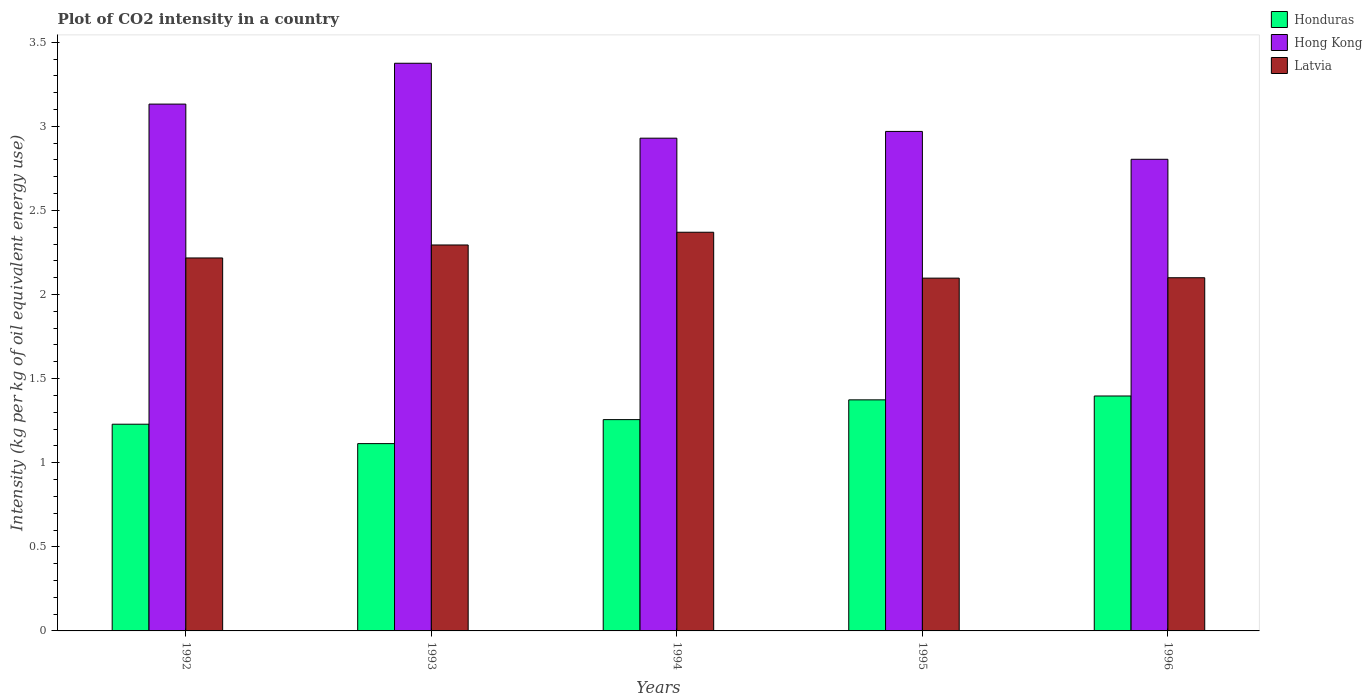How many groups of bars are there?
Provide a short and direct response. 5. How many bars are there on the 3rd tick from the left?
Make the answer very short. 3. What is the label of the 4th group of bars from the left?
Provide a succinct answer. 1995. In how many cases, is the number of bars for a given year not equal to the number of legend labels?
Your response must be concise. 0. What is the CO2 intensity in in Latvia in 1996?
Your answer should be compact. 2.1. Across all years, what is the maximum CO2 intensity in in Latvia?
Provide a succinct answer. 2.37. Across all years, what is the minimum CO2 intensity in in Latvia?
Offer a terse response. 2.1. In which year was the CO2 intensity in in Latvia maximum?
Ensure brevity in your answer.  1994. What is the total CO2 intensity in in Honduras in the graph?
Give a very brief answer. 6.37. What is the difference between the CO2 intensity in in Latvia in 1995 and that in 1996?
Offer a terse response. -0. What is the difference between the CO2 intensity in in Latvia in 1993 and the CO2 intensity in in Honduras in 1996?
Offer a very short reply. 0.9. What is the average CO2 intensity in in Latvia per year?
Keep it short and to the point. 2.22. In the year 1993, what is the difference between the CO2 intensity in in Latvia and CO2 intensity in in Honduras?
Your response must be concise. 1.18. In how many years, is the CO2 intensity in in Honduras greater than 2.1 kg?
Offer a very short reply. 0. What is the ratio of the CO2 intensity in in Hong Kong in 1992 to that in 1993?
Your answer should be very brief. 0.93. Is the CO2 intensity in in Hong Kong in 1992 less than that in 1996?
Ensure brevity in your answer.  No. Is the difference between the CO2 intensity in in Latvia in 1992 and 1996 greater than the difference between the CO2 intensity in in Honduras in 1992 and 1996?
Provide a succinct answer. Yes. What is the difference between the highest and the second highest CO2 intensity in in Honduras?
Make the answer very short. 0.02. What is the difference between the highest and the lowest CO2 intensity in in Honduras?
Provide a succinct answer. 0.28. In how many years, is the CO2 intensity in in Hong Kong greater than the average CO2 intensity in in Hong Kong taken over all years?
Give a very brief answer. 2. Is the sum of the CO2 intensity in in Hong Kong in 1992 and 1994 greater than the maximum CO2 intensity in in Honduras across all years?
Your response must be concise. Yes. What does the 2nd bar from the left in 1992 represents?
Provide a short and direct response. Hong Kong. What does the 2nd bar from the right in 1993 represents?
Give a very brief answer. Hong Kong. Does the graph contain any zero values?
Keep it short and to the point. No. Where does the legend appear in the graph?
Make the answer very short. Top right. What is the title of the graph?
Give a very brief answer. Plot of CO2 intensity in a country. What is the label or title of the Y-axis?
Offer a terse response. Intensity (kg per kg of oil equivalent energy use). What is the Intensity (kg per kg of oil equivalent energy use) in Honduras in 1992?
Give a very brief answer. 1.23. What is the Intensity (kg per kg of oil equivalent energy use) of Hong Kong in 1992?
Offer a terse response. 3.13. What is the Intensity (kg per kg of oil equivalent energy use) of Latvia in 1992?
Your response must be concise. 2.22. What is the Intensity (kg per kg of oil equivalent energy use) of Honduras in 1993?
Offer a terse response. 1.11. What is the Intensity (kg per kg of oil equivalent energy use) of Hong Kong in 1993?
Provide a short and direct response. 3.38. What is the Intensity (kg per kg of oil equivalent energy use) of Latvia in 1993?
Keep it short and to the point. 2.29. What is the Intensity (kg per kg of oil equivalent energy use) of Honduras in 1994?
Ensure brevity in your answer.  1.26. What is the Intensity (kg per kg of oil equivalent energy use) of Hong Kong in 1994?
Your response must be concise. 2.93. What is the Intensity (kg per kg of oil equivalent energy use) in Latvia in 1994?
Your answer should be compact. 2.37. What is the Intensity (kg per kg of oil equivalent energy use) of Honduras in 1995?
Provide a short and direct response. 1.37. What is the Intensity (kg per kg of oil equivalent energy use) of Hong Kong in 1995?
Keep it short and to the point. 2.97. What is the Intensity (kg per kg of oil equivalent energy use) of Latvia in 1995?
Your answer should be very brief. 2.1. What is the Intensity (kg per kg of oil equivalent energy use) of Honduras in 1996?
Ensure brevity in your answer.  1.4. What is the Intensity (kg per kg of oil equivalent energy use) in Hong Kong in 1996?
Give a very brief answer. 2.8. What is the Intensity (kg per kg of oil equivalent energy use) in Latvia in 1996?
Provide a short and direct response. 2.1. Across all years, what is the maximum Intensity (kg per kg of oil equivalent energy use) of Honduras?
Provide a short and direct response. 1.4. Across all years, what is the maximum Intensity (kg per kg of oil equivalent energy use) of Hong Kong?
Your response must be concise. 3.38. Across all years, what is the maximum Intensity (kg per kg of oil equivalent energy use) in Latvia?
Offer a very short reply. 2.37. Across all years, what is the minimum Intensity (kg per kg of oil equivalent energy use) in Honduras?
Provide a short and direct response. 1.11. Across all years, what is the minimum Intensity (kg per kg of oil equivalent energy use) in Hong Kong?
Make the answer very short. 2.8. Across all years, what is the minimum Intensity (kg per kg of oil equivalent energy use) in Latvia?
Your answer should be compact. 2.1. What is the total Intensity (kg per kg of oil equivalent energy use) of Honduras in the graph?
Give a very brief answer. 6.37. What is the total Intensity (kg per kg of oil equivalent energy use) of Hong Kong in the graph?
Give a very brief answer. 15.21. What is the total Intensity (kg per kg of oil equivalent energy use) of Latvia in the graph?
Give a very brief answer. 11.08. What is the difference between the Intensity (kg per kg of oil equivalent energy use) in Honduras in 1992 and that in 1993?
Make the answer very short. 0.12. What is the difference between the Intensity (kg per kg of oil equivalent energy use) of Hong Kong in 1992 and that in 1993?
Your answer should be very brief. -0.24. What is the difference between the Intensity (kg per kg of oil equivalent energy use) of Latvia in 1992 and that in 1993?
Provide a short and direct response. -0.08. What is the difference between the Intensity (kg per kg of oil equivalent energy use) in Honduras in 1992 and that in 1994?
Ensure brevity in your answer.  -0.03. What is the difference between the Intensity (kg per kg of oil equivalent energy use) of Hong Kong in 1992 and that in 1994?
Offer a terse response. 0.2. What is the difference between the Intensity (kg per kg of oil equivalent energy use) of Latvia in 1992 and that in 1994?
Give a very brief answer. -0.15. What is the difference between the Intensity (kg per kg of oil equivalent energy use) in Honduras in 1992 and that in 1995?
Provide a succinct answer. -0.14. What is the difference between the Intensity (kg per kg of oil equivalent energy use) of Hong Kong in 1992 and that in 1995?
Ensure brevity in your answer.  0.16. What is the difference between the Intensity (kg per kg of oil equivalent energy use) in Latvia in 1992 and that in 1995?
Give a very brief answer. 0.12. What is the difference between the Intensity (kg per kg of oil equivalent energy use) of Honduras in 1992 and that in 1996?
Keep it short and to the point. -0.17. What is the difference between the Intensity (kg per kg of oil equivalent energy use) of Hong Kong in 1992 and that in 1996?
Keep it short and to the point. 0.33. What is the difference between the Intensity (kg per kg of oil equivalent energy use) in Latvia in 1992 and that in 1996?
Offer a terse response. 0.12. What is the difference between the Intensity (kg per kg of oil equivalent energy use) of Honduras in 1993 and that in 1994?
Your answer should be compact. -0.14. What is the difference between the Intensity (kg per kg of oil equivalent energy use) in Hong Kong in 1993 and that in 1994?
Offer a very short reply. 0.45. What is the difference between the Intensity (kg per kg of oil equivalent energy use) of Latvia in 1993 and that in 1994?
Your response must be concise. -0.08. What is the difference between the Intensity (kg per kg of oil equivalent energy use) of Honduras in 1993 and that in 1995?
Keep it short and to the point. -0.26. What is the difference between the Intensity (kg per kg of oil equivalent energy use) in Hong Kong in 1993 and that in 1995?
Provide a short and direct response. 0.41. What is the difference between the Intensity (kg per kg of oil equivalent energy use) of Latvia in 1993 and that in 1995?
Keep it short and to the point. 0.2. What is the difference between the Intensity (kg per kg of oil equivalent energy use) in Honduras in 1993 and that in 1996?
Your response must be concise. -0.28. What is the difference between the Intensity (kg per kg of oil equivalent energy use) in Hong Kong in 1993 and that in 1996?
Offer a terse response. 0.57. What is the difference between the Intensity (kg per kg of oil equivalent energy use) of Latvia in 1993 and that in 1996?
Provide a short and direct response. 0.19. What is the difference between the Intensity (kg per kg of oil equivalent energy use) in Honduras in 1994 and that in 1995?
Provide a short and direct response. -0.12. What is the difference between the Intensity (kg per kg of oil equivalent energy use) in Hong Kong in 1994 and that in 1995?
Give a very brief answer. -0.04. What is the difference between the Intensity (kg per kg of oil equivalent energy use) in Latvia in 1994 and that in 1995?
Offer a terse response. 0.27. What is the difference between the Intensity (kg per kg of oil equivalent energy use) of Honduras in 1994 and that in 1996?
Your answer should be compact. -0.14. What is the difference between the Intensity (kg per kg of oil equivalent energy use) in Hong Kong in 1994 and that in 1996?
Provide a succinct answer. 0.13. What is the difference between the Intensity (kg per kg of oil equivalent energy use) of Latvia in 1994 and that in 1996?
Offer a very short reply. 0.27. What is the difference between the Intensity (kg per kg of oil equivalent energy use) of Honduras in 1995 and that in 1996?
Keep it short and to the point. -0.02. What is the difference between the Intensity (kg per kg of oil equivalent energy use) of Hong Kong in 1995 and that in 1996?
Offer a very short reply. 0.17. What is the difference between the Intensity (kg per kg of oil equivalent energy use) in Latvia in 1995 and that in 1996?
Your answer should be very brief. -0. What is the difference between the Intensity (kg per kg of oil equivalent energy use) of Honduras in 1992 and the Intensity (kg per kg of oil equivalent energy use) of Hong Kong in 1993?
Ensure brevity in your answer.  -2.15. What is the difference between the Intensity (kg per kg of oil equivalent energy use) in Honduras in 1992 and the Intensity (kg per kg of oil equivalent energy use) in Latvia in 1993?
Your answer should be compact. -1.07. What is the difference between the Intensity (kg per kg of oil equivalent energy use) of Hong Kong in 1992 and the Intensity (kg per kg of oil equivalent energy use) of Latvia in 1993?
Ensure brevity in your answer.  0.84. What is the difference between the Intensity (kg per kg of oil equivalent energy use) in Honduras in 1992 and the Intensity (kg per kg of oil equivalent energy use) in Hong Kong in 1994?
Provide a succinct answer. -1.7. What is the difference between the Intensity (kg per kg of oil equivalent energy use) of Honduras in 1992 and the Intensity (kg per kg of oil equivalent energy use) of Latvia in 1994?
Provide a succinct answer. -1.14. What is the difference between the Intensity (kg per kg of oil equivalent energy use) of Hong Kong in 1992 and the Intensity (kg per kg of oil equivalent energy use) of Latvia in 1994?
Provide a succinct answer. 0.76. What is the difference between the Intensity (kg per kg of oil equivalent energy use) of Honduras in 1992 and the Intensity (kg per kg of oil equivalent energy use) of Hong Kong in 1995?
Give a very brief answer. -1.74. What is the difference between the Intensity (kg per kg of oil equivalent energy use) of Honduras in 1992 and the Intensity (kg per kg of oil equivalent energy use) of Latvia in 1995?
Provide a short and direct response. -0.87. What is the difference between the Intensity (kg per kg of oil equivalent energy use) in Hong Kong in 1992 and the Intensity (kg per kg of oil equivalent energy use) in Latvia in 1995?
Your answer should be very brief. 1.03. What is the difference between the Intensity (kg per kg of oil equivalent energy use) of Honduras in 1992 and the Intensity (kg per kg of oil equivalent energy use) of Hong Kong in 1996?
Give a very brief answer. -1.58. What is the difference between the Intensity (kg per kg of oil equivalent energy use) in Honduras in 1992 and the Intensity (kg per kg of oil equivalent energy use) in Latvia in 1996?
Give a very brief answer. -0.87. What is the difference between the Intensity (kg per kg of oil equivalent energy use) of Hong Kong in 1992 and the Intensity (kg per kg of oil equivalent energy use) of Latvia in 1996?
Keep it short and to the point. 1.03. What is the difference between the Intensity (kg per kg of oil equivalent energy use) in Honduras in 1993 and the Intensity (kg per kg of oil equivalent energy use) in Hong Kong in 1994?
Provide a succinct answer. -1.82. What is the difference between the Intensity (kg per kg of oil equivalent energy use) of Honduras in 1993 and the Intensity (kg per kg of oil equivalent energy use) of Latvia in 1994?
Give a very brief answer. -1.26. What is the difference between the Intensity (kg per kg of oil equivalent energy use) in Honduras in 1993 and the Intensity (kg per kg of oil equivalent energy use) in Hong Kong in 1995?
Provide a succinct answer. -1.86. What is the difference between the Intensity (kg per kg of oil equivalent energy use) of Honduras in 1993 and the Intensity (kg per kg of oil equivalent energy use) of Latvia in 1995?
Offer a terse response. -0.98. What is the difference between the Intensity (kg per kg of oil equivalent energy use) of Hong Kong in 1993 and the Intensity (kg per kg of oil equivalent energy use) of Latvia in 1995?
Your answer should be very brief. 1.28. What is the difference between the Intensity (kg per kg of oil equivalent energy use) of Honduras in 1993 and the Intensity (kg per kg of oil equivalent energy use) of Hong Kong in 1996?
Your answer should be very brief. -1.69. What is the difference between the Intensity (kg per kg of oil equivalent energy use) in Honduras in 1993 and the Intensity (kg per kg of oil equivalent energy use) in Latvia in 1996?
Ensure brevity in your answer.  -0.99. What is the difference between the Intensity (kg per kg of oil equivalent energy use) in Hong Kong in 1993 and the Intensity (kg per kg of oil equivalent energy use) in Latvia in 1996?
Keep it short and to the point. 1.28. What is the difference between the Intensity (kg per kg of oil equivalent energy use) in Honduras in 1994 and the Intensity (kg per kg of oil equivalent energy use) in Hong Kong in 1995?
Your answer should be compact. -1.71. What is the difference between the Intensity (kg per kg of oil equivalent energy use) of Honduras in 1994 and the Intensity (kg per kg of oil equivalent energy use) of Latvia in 1995?
Provide a short and direct response. -0.84. What is the difference between the Intensity (kg per kg of oil equivalent energy use) in Hong Kong in 1994 and the Intensity (kg per kg of oil equivalent energy use) in Latvia in 1995?
Make the answer very short. 0.83. What is the difference between the Intensity (kg per kg of oil equivalent energy use) in Honduras in 1994 and the Intensity (kg per kg of oil equivalent energy use) in Hong Kong in 1996?
Provide a short and direct response. -1.55. What is the difference between the Intensity (kg per kg of oil equivalent energy use) of Honduras in 1994 and the Intensity (kg per kg of oil equivalent energy use) of Latvia in 1996?
Your answer should be very brief. -0.84. What is the difference between the Intensity (kg per kg of oil equivalent energy use) in Hong Kong in 1994 and the Intensity (kg per kg of oil equivalent energy use) in Latvia in 1996?
Provide a succinct answer. 0.83. What is the difference between the Intensity (kg per kg of oil equivalent energy use) of Honduras in 1995 and the Intensity (kg per kg of oil equivalent energy use) of Hong Kong in 1996?
Provide a short and direct response. -1.43. What is the difference between the Intensity (kg per kg of oil equivalent energy use) in Honduras in 1995 and the Intensity (kg per kg of oil equivalent energy use) in Latvia in 1996?
Your answer should be compact. -0.73. What is the difference between the Intensity (kg per kg of oil equivalent energy use) in Hong Kong in 1995 and the Intensity (kg per kg of oil equivalent energy use) in Latvia in 1996?
Offer a very short reply. 0.87. What is the average Intensity (kg per kg of oil equivalent energy use) of Honduras per year?
Your response must be concise. 1.27. What is the average Intensity (kg per kg of oil equivalent energy use) in Hong Kong per year?
Make the answer very short. 3.04. What is the average Intensity (kg per kg of oil equivalent energy use) of Latvia per year?
Provide a succinct answer. 2.22. In the year 1992, what is the difference between the Intensity (kg per kg of oil equivalent energy use) in Honduras and Intensity (kg per kg of oil equivalent energy use) in Hong Kong?
Provide a short and direct response. -1.9. In the year 1992, what is the difference between the Intensity (kg per kg of oil equivalent energy use) of Honduras and Intensity (kg per kg of oil equivalent energy use) of Latvia?
Your answer should be compact. -0.99. In the year 1992, what is the difference between the Intensity (kg per kg of oil equivalent energy use) in Hong Kong and Intensity (kg per kg of oil equivalent energy use) in Latvia?
Provide a short and direct response. 0.91. In the year 1993, what is the difference between the Intensity (kg per kg of oil equivalent energy use) in Honduras and Intensity (kg per kg of oil equivalent energy use) in Hong Kong?
Offer a terse response. -2.26. In the year 1993, what is the difference between the Intensity (kg per kg of oil equivalent energy use) in Honduras and Intensity (kg per kg of oil equivalent energy use) in Latvia?
Offer a terse response. -1.18. In the year 1993, what is the difference between the Intensity (kg per kg of oil equivalent energy use) in Hong Kong and Intensity (kg per kg of oil equivalent energy use) in Latvia?
Give a very brief answer. 1.08. In the year 1994, what is the difference between the Intensity (kg per kg of oil equivalent energy use) of Honduras and Intensity (kg per kg of oil equivalent energy use) of Hong Kong?
Offer a very short reply. -1.67. In the year 1994, what is the difference between the Intensity (kg per kg of oil equivalent energy use) in Honduras and Intensity (kg per kg of oil equivalent energy use) in Latvia?
Ensure brevity in your answer.  -1.11. In the year 1994, what is the difference between the Intensity (kg per kg of oil equivalent energy use) in Hong Kong and Intensity (kg per kg of oil equivalent energy use) in Latvia?
Your answer should be compact. 0.56. In the year 1995, what is the difference between the Intensity (kg per kg of oil equivalent energy use) in Honduras and Intensity (kg per kg of oil equivalent energy use) in Hong Kong?
Provide a succinct answer. -1.6. In the year 1995, what is the difference between the Intensity (kg per kg of oil equivalent energy use) in Honduras and Intensity (kg per kg of oil equivalent energy use) in Latvia?
Your answer should be compact. -0.72. In the year 1995, what is the difference between the Intensity (kg per kg of oil equivalent energy use) in Hong Kong and Intensity (kg per kg of oil equivalent energy use) in Latvia?
Provide a short and direct response. 0.87. In the year 1996, what is the difference between the Intensity (kg per kg of oil equivalent energy use) in Honduras and Intensity (kg per kg of oil equivalent energy use) in Hong Kong?
Offer a terse response. -1.41. In the year 1996, what is the difference between the Intensity (kg per kg of oil equivalent energy use) of Honduras and Intensity (kg per kg of oil equivalent energy use) of Latvia?
Offer a terse response. -0.7. In the year 1996, what is the difference between the Intensity (kg per kg of oil equivalent energy use) in Hong Kong and Intensity (kg per kg of oil equivalent energy use) in Latvia?
Provide a succinct answer. 0.7. What is the ratio of the Intensity (kg per kg of oil equivalent energy use) in Honduras in 1992 to that in 1993?
Give a very brief answer. 1.1. What is the ratio of the Intensity (kg per kg of oil equivalent energy use) of Hong Kong in 1992 to that in 1993?
Provide a short and direct response. 0.93. What is the ratio of the Intensity (kg per kg of oil equivalent energy use) in Latvia in 1992 to that in 1993?
Keep it short and to the point. 0.97. What is the ratio of the Intensity (kg per kg of oil equivalent energy use) in Honduras in 1992 to that in 1994?
Keep it short and to the point. 0.98. What is the ratio of the Intensity (kg per kg of oil equivalent energy use) in Hong Kong in 1992 to that in 1994?
Your response must be concise. 1.07. What is the ratio of the Intensity (kg per kg of oil equivalent energy use) in Latvia in 1992 to that in 1994?
Your response must be concise. 0.94. What is the ratio of the Intensity (kg per kg of oil equivalent energy use) in Honduras in 1992 to that in 1995?
Your answer should be very brief. 0.89. What is the ratio of the Intensity (kg per kg of oil equivalent energy use) in Hong Kong in 1992 to that in 1995?
Your response must be concise. 1.05. What is the ratio of the Intensity (kg per kg of oil equivalent energy use) of Latvia in 1992 to that in 1995?
Give a very brief answer. 1.06. What is the ratio of the Intensity (kg per kg of oil equivalent energy use) of Honduras in 1992 to that in 1996?
Provide a short and direct response. 0.88. What is the ratio of the Intensity (kg per kg of oil equivalent energy use) in Hong Kong in 1992 to that in 1996?
Ensure brevity in your answer.  1.12. What is the ratio of the Intensity (kg per kg of oil equivalent energy use) in Latvia in 1992 to that in 1996?
Ensure brevity in your answer.  1.06. What is the ratio of the Intensity (kg per kg of oil equivalent energy use) in Honduras in 1993 to that in 1994?
Provide a short and direct response. 0.89. What is the ratio of the Intensity (kg per kg of oil equivalent energy use) in Hong Kong in 1993 to that in 1994?
Offer a very short reply. 1.15. What is the ratio of the Intensity (kg per kg of oil equivalent energy use) in Latvia in 1993 to that in 1994?
Offer a very short reply. 0.97. What is the ratio of the Intensity (kg per kg of oil equivalent energy use) of Honduras in 1993 to that in 1995?
Ensure brevity in your answer.  0.81. What is the ratio of the Intensity (kg per kg of oil equivalent energy use) in Hong Kong in 1993 to that in 1995?
Offer a very short reply. 1.14. What is the ratio of the Intensity (kg per kg of oil equivalent energy use) of Latvia in 1993 to that in 1995?
Your answer should be compact. 1.09. What is the ratio of the Intensity (kg per kg of oil equivalent energy use) of Honduras in 1993 to that in 1996?
Ensure brevity in your answer.  0.8. What is the ratio of the Intensity (kg per kg of oil equivalent energy use) of Hong Kong in 1993 to that in 1996?
Give a very brief answer. 1.2. What is the ratio of the Intensity (kg per kg of oil equivalent energy use) of Latvia in 1993 to that in 1996?
Keep it short and to the point. 1.09. What is the ratio of the Intensity (kg per kg of oil equivalent energy use) of Honduras in 1994 to that in 1995?
Offer a very short reply. 0.91. What is the ratio of the Intensity (kg per kg of oil equivalent energy use) of Hong Kong in 1994 to that in 1995?
Give a very brief answer. 0.99. What is the ratio of the Intensity (kg per kg of oil equivalent energy use) in Latvia in 1994 to that in 1995?
Offer a terse response. 1.13. What is the ratio of the Intensity (kg per kg of oil equivalent energy use) of Honduras in 1994 to that in 1996?
Your answer should be compact. 0.9. What is the ratio of the Intensity (kg per kg of oil equivalent energy use) in Hong Kong in 1994 to that in 1996?
Provide a succinct answer. 1.04. What is the ratio of the Intensity (kg per kg of oil equivalent energy use) of Latvia in 1994 to that in 1996?
Give a very brief answer. 1.13. What is the ratio of the Intensity (kg per kg of oil equivalent energy use) in Honduras in 1995 to that in 1996?
Give a very brief answer. 0.98. What is the ratio of the Intensity (kg per kg of oil equivalent energy use) in Hong Kong in 1995 to that in 1996?
Ensure brevity in your answer.  1.06. What is the difference between the highest and the second highest Intensity (kg per kg of oil equivalent energy use) of Honduras?
Offer a very short reply. 0.02. What is the difference between the highest and the second highest Intensity (kg per kg of oil equivalent energy use) in Hong Kong?
Your answer should be compact. 0.24. What is the difference between the highest and the second highest Intensity (kg per kg of oil equivalent energy use) in Latvia?
Provide a short and direct response. 0.08. What is the difference between the highest and the lowest Intensity (kg per kg of oil equivalent energy use) of Honduras?
Your answer should be very brief. 0.28. What is the difference between the highest and the lowest Intensity (kg per kg of oil equivalent energy use) of Hong Kong?
Ensure brevity in your answer.  0.57. What is the difference between the highest and the lowest Intensity (kg per kg of oil equivalent energy use) of Latvia?
Your response must be concise. 0.27. 